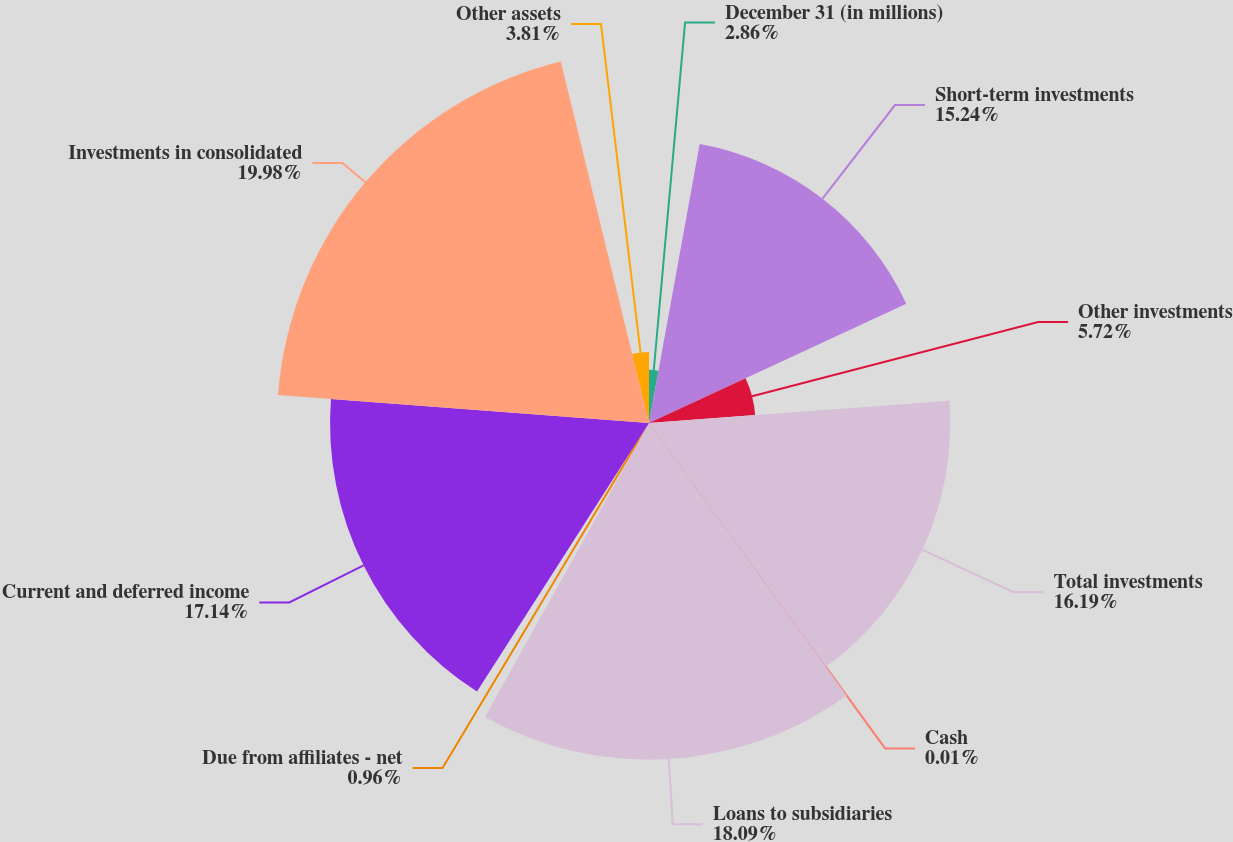Convert chart to OTSL. <chart><loc_0><loc_0><loc_500><loc_500><pie_chart><fcel>December 31 (in millions)<fcel>Short-term investments<fcel>Other investments<fcel>Total investments<fcel>Cash<fcel>Loans to subsidiaries<fcel>Due from affiliates - net<fcel>Current and deferred income<fcel>Investments in consolidated<fcel>Other assets<nl><fcel>2.86%<fcel>15.24%<fcel>5.72%<fcel>16.19%<fcel>0.01%<fcel>18.09%<fcel>0.96%<fcel>17.14%<fcel>19.99%<fcel>3.81%<nl></chart> 